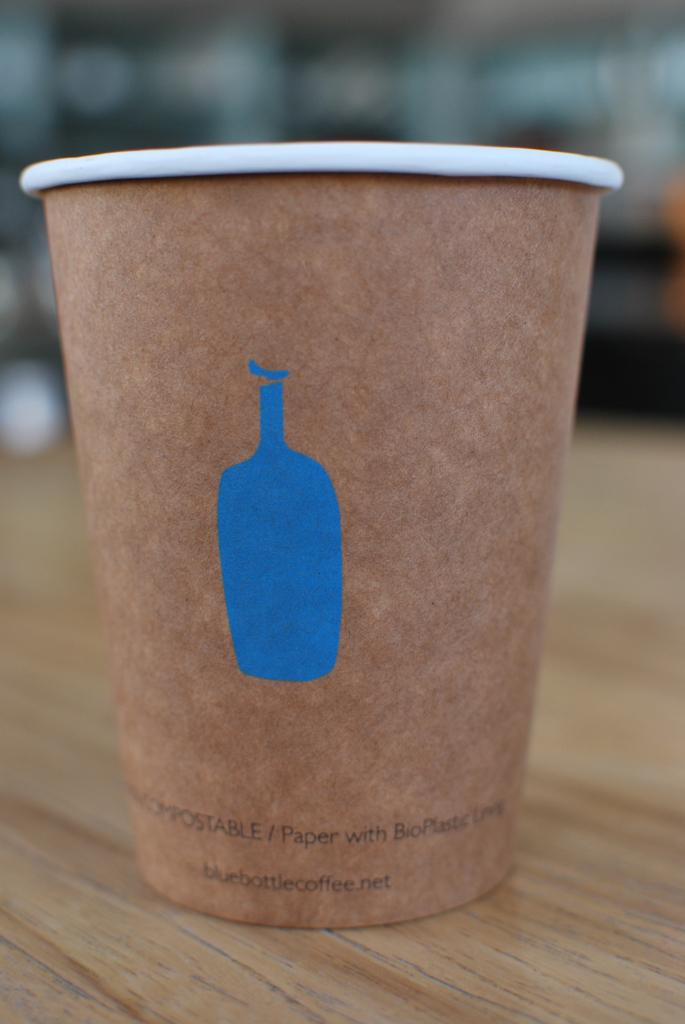What object is present in the image? There is a cup in the image. What is depicted on the cup? The cup has a figure and text on it. What is the cup placed on? The cup is placed on a wooden surface. How would you describe the background of the image? The background of the image is blurred. What is the rate of the rod in the image? There is no rod or rate mentioned in the image; it only features a cup with a figure and text on it, placed on a wooden surface with a blurred background. 